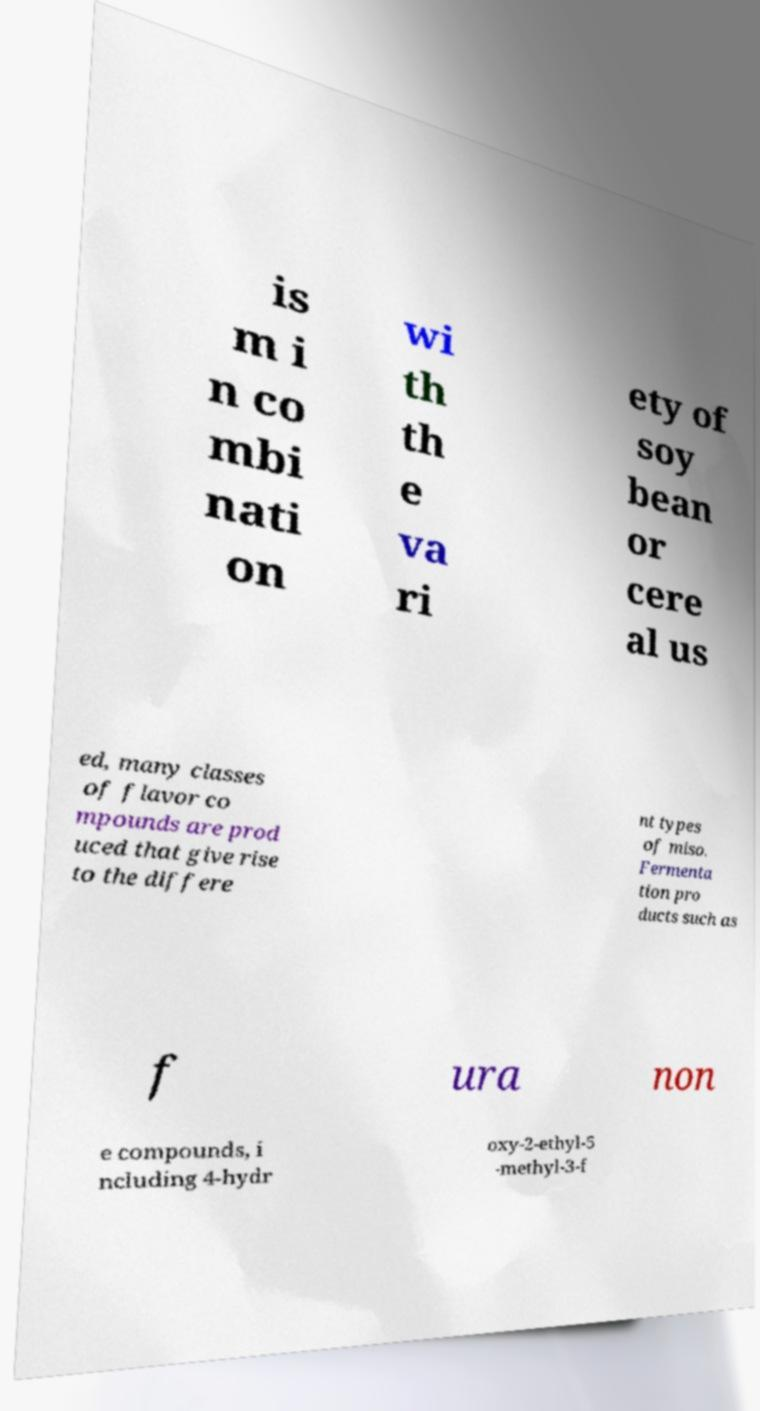Can you accurately transcribe the text from the provided image for me? is m i n co mbi nati on wi th th e va ri ety of soy bean or cere al us ed, many classes of flavor co mpounds are prod uced that give rise to the differe nt types of miso. Fermenta tion pro ducts such as f ura non e compounds, i ncluding 4-hydr oxy-2-ethyl-5 -methyl-3-f 